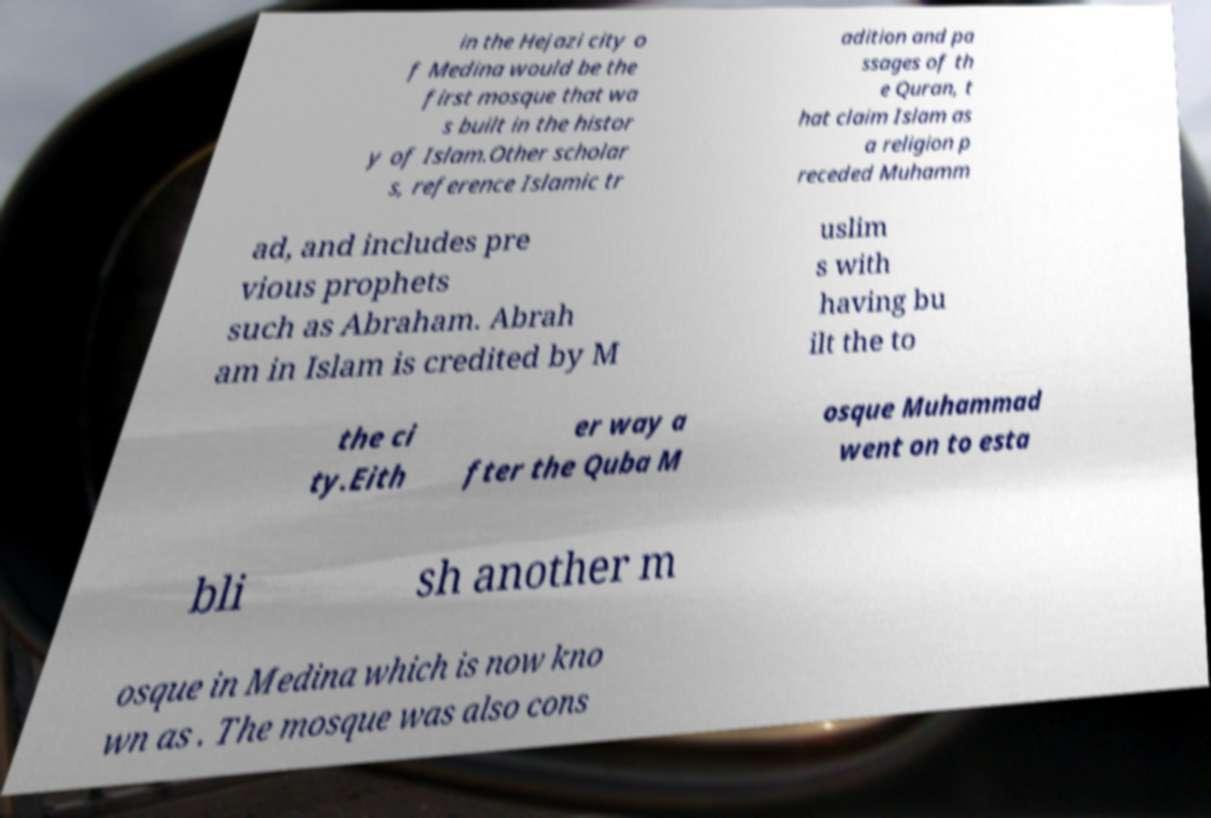For documentation purposes, I need the text within this image transcribed. Could you provide that? in the Hejazi city o f Medina would be the first mosque that wa s built in the histor y of Islam.Other scholar s, reference Islamic tr adition and pa ssages of th e Quran, t hat claim Islam as a religion p receded Muhamm ad, and includes pre vious prophets such as Abraham. Abrah am in Islam is credited by M uslim s with having bu ilt the to the ci ty.Eith er way a fter the Quba M osque Muhammad went on to esta bli sh another m osque in Medina which is now kno wn as . The mosque was also cons 